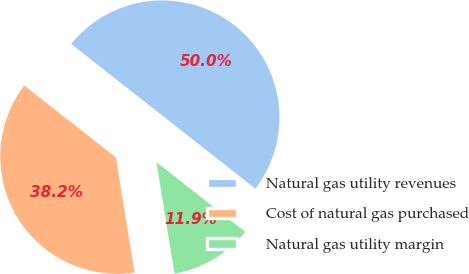Convert chart. <chart><loc_0><loc_0><loc_500><loc_500><pie_chart><fcel>Natural gas utility revenues<fcel>Cost of natural gas purchased<fcel>Natural gas utility margin<nl><fcel>50.0%<fcel>38.15%<fcel>11.85%<nl></chart> 